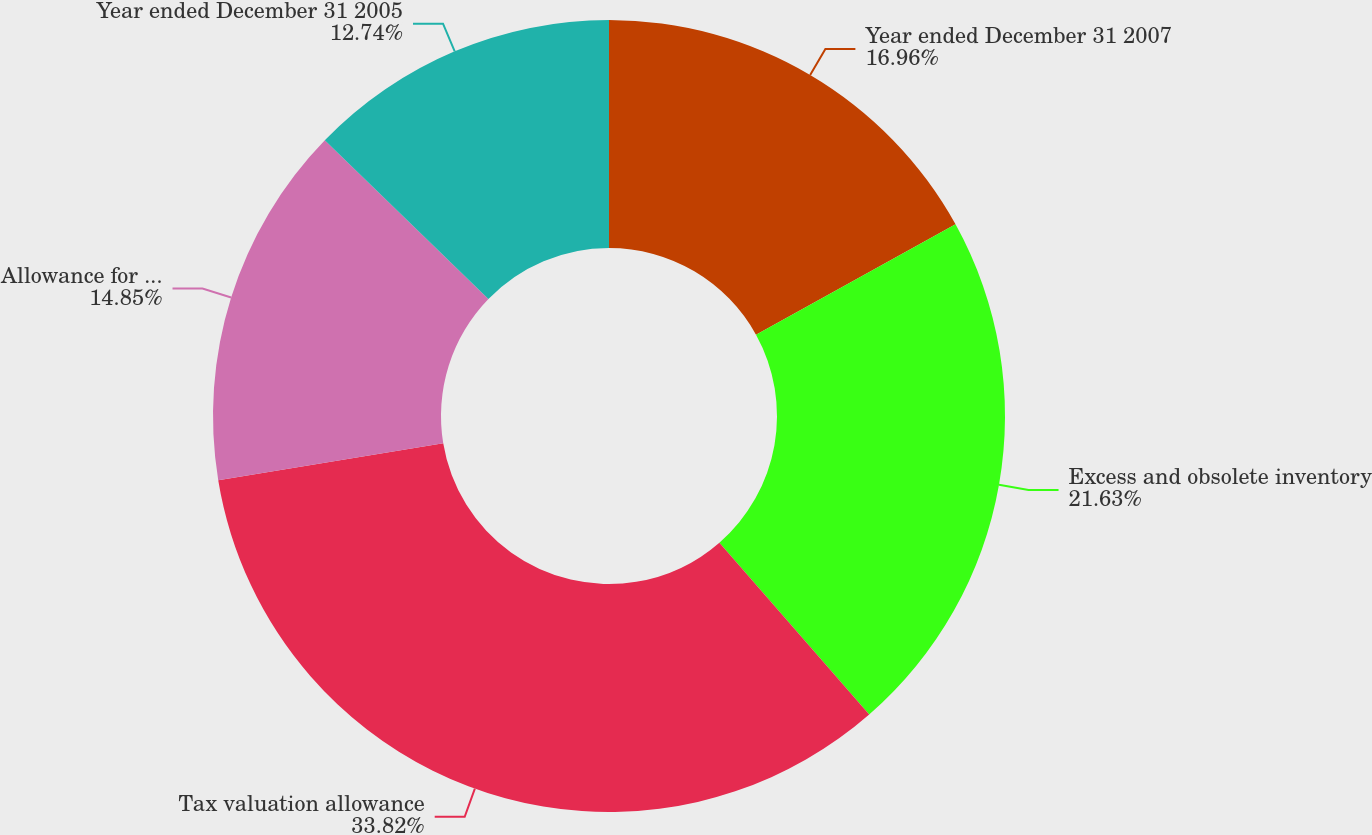Convert chart to OTSL. <chart><loc_0><loc_0><loc_500><loc_500><pie_chart><fcel>Year ended December 31 2007<fcel>Excess and obsolete inventory<fcel>Tax valuation allowance<fcel>Allowance for doubtful<fcel>Year ended December 31 2005<nl><fcel>16.96%<fcel>21.63%<fcel>33.82%<fcel>14.85%<fcel>12.74%<nl></chart> 